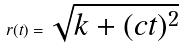Convert formula to latex. <formula><loc_0><loc_0><loc_500><loc_500>r ( t ) = \sqrt { k + ( c t ) ^ { 2 } }</formula> 